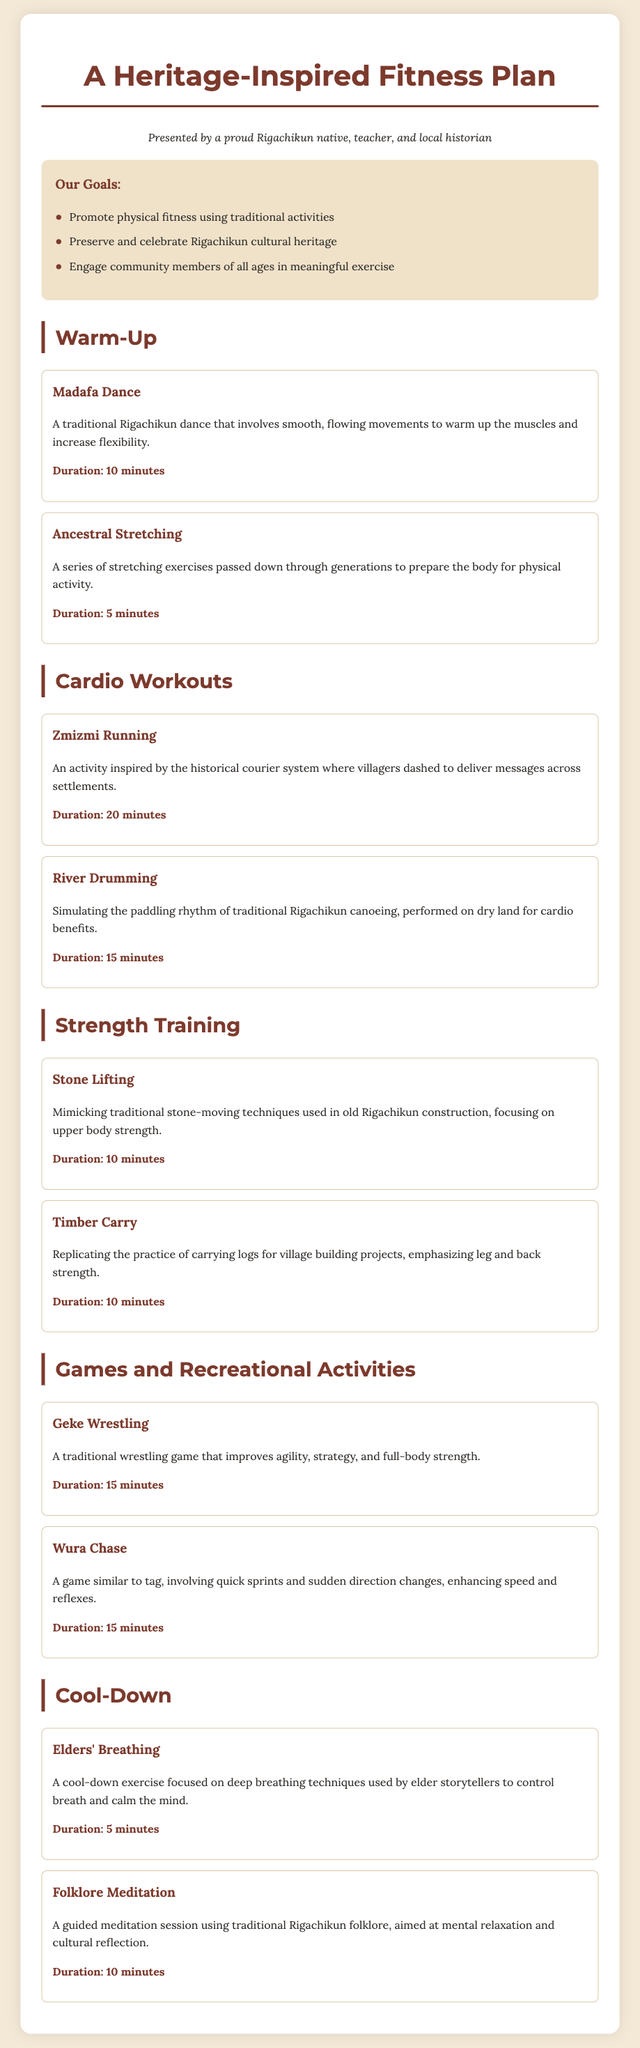what is the title of the document? The title of the document is prominently displayed at the top.
Answer: A Heritage-Inspired Fitness Plan how long is the duration of Zmizmi Running? The duration is specified in the cardio workouts section.
Answer: 20 minutes what is the first activity listed in the warm-up section? The first activity is mentioned in the warm-up section of the document.
Answer: Madafa Dance name one goal of the fitness plan. The goals are listed in a specific section of the document.
Answer: Promote physical fitness using traditional activities which activity focuses on deep breathing techniques? This activity is part of the cool-down section.
Answer: Elders' Breathing what type of game is Geke? The description of Geke is included in the games and recreational activities section.
Answer: Wrestling how long should the cool-down session last in total? The total duration is calculated by adding the cool-down activities' durations.
Answer: 15 minutes which section contains Ancestral Stretching? The section is clearly labeled in the document structure.
Answer: Warm-Up 